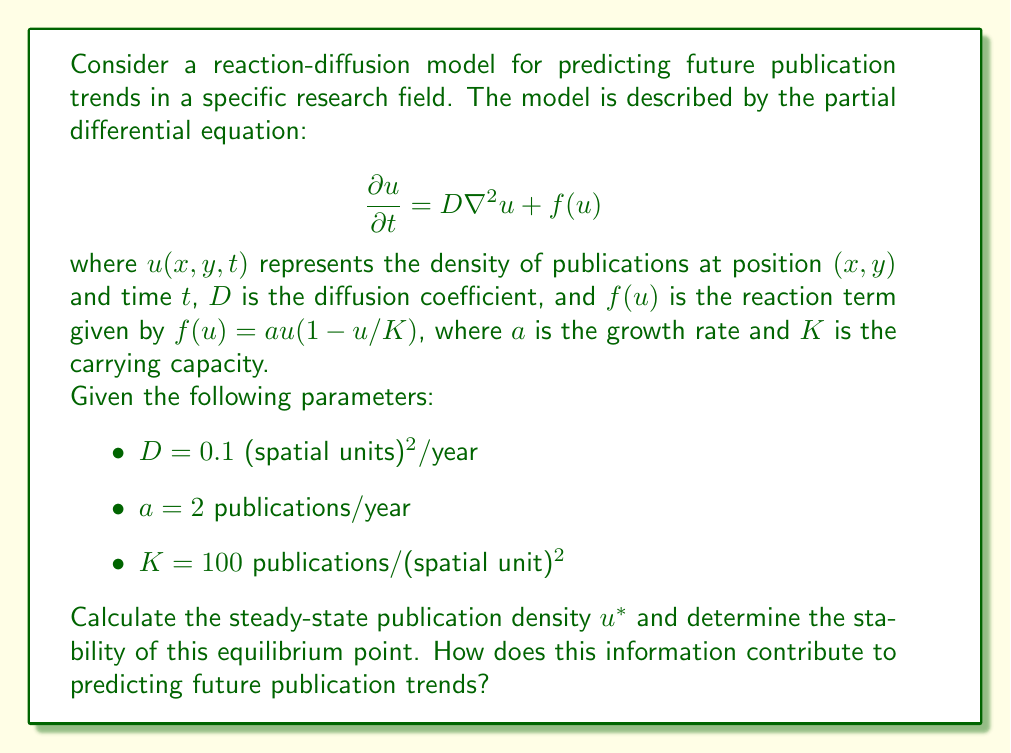What is the answer to this math problem? To solve this problem, we'll follow these steps:

1. Find the steady-state solution:
   At steady-state, $\frac{\partial u}{\partial t} = 0$, and assuming spatial homogeneity, $\nabla^2u = 0$. Therefore:

   $$0 = f(u^*) = au^*(1-u^*/K)$$

2. Solve for $u^*$:
   There are two solutions to this equation:
   $$u^* = 0$$ or $$u^* = K = 100$$

3. Analyze stability:
   To determine stability, we evaluate $\frac{df}{du}$ at each equilibrium point:

   $$\frac{df}{du} = a(1-2u/K)$$

   At $u^* = 0$: $\frac{df}{du} = a = 2 > 0$ (unstable)
   At $u^* = K = 100$: $\frac{df}{du} = -a = -2 < 0$ (stable)

4. Interpret results:
   The stable equilibrium at $u^* = K = 100$ publications/(spatial unit)$^2$ suggests that the publication density will tend towards this value over time. This indicates a saturation point in the field, where the number of publications reaches a maximum sustainable level.

5. Predict future trends:
   - If the current publication density is below 100, we expect it to increase towards this value.
   - If it's above 100, we expect it to decrease towards 100.
   - The rate of approach to this equilibrium is influenced by the diffusion coefficient $D$ and growth rate $a$.

This model provides a quantitative basis for predicting future publication trends, allowing for data-driven decision-making in hiring and resource allocation. It suggests that fields approaching or at the carrying capacity may have limited growth potential, while those well below it may be more promising for future expansion.
Answer: The steady-state publication density is $u^* = 100$ publications/(spatial unit)$^2$, which is a stable equilibrium point. This indicates that the publication density in the field will tend towards this saturation level over time, providing a quantitative prediction for future publication trends. 